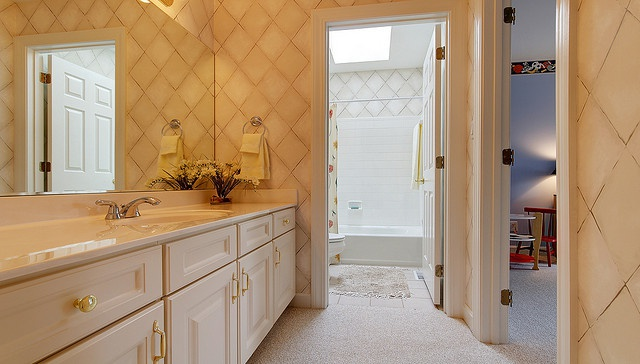Describe the objects in this image and their specific colors. I can see potted plant in tan, olive, maroon, black, and orange tones, potted plant in tan, olive, black, maroon, and orange tones, chair in tan, black, maroon, and gray tones, sink in tan tones, and toilet in tan, darkgray, lightgray, and gray tones in this image. 